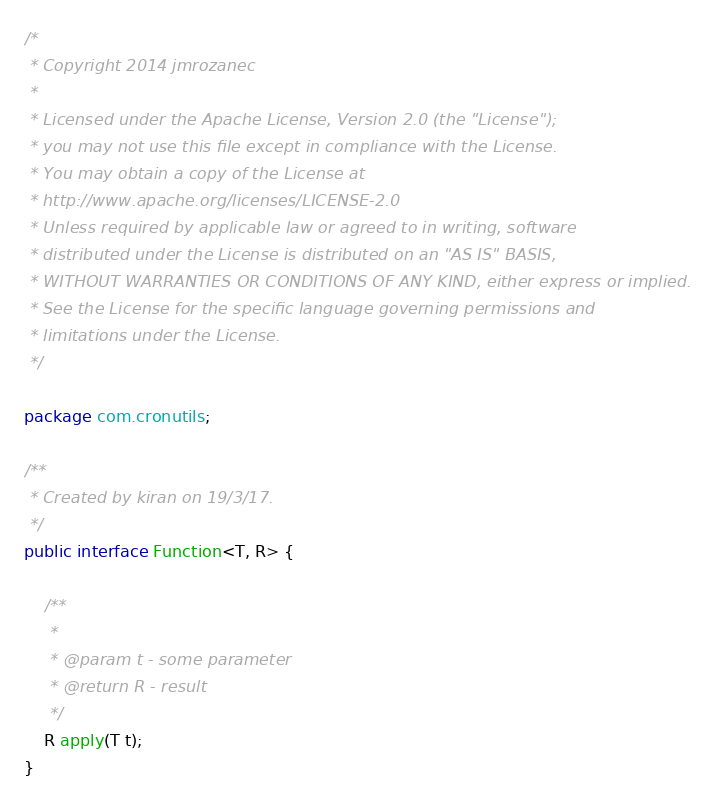<code> <loc_0><loc_0><loc_500><loc_500><_Java_>/*
 * Copyright 2014 jmrozanec
 *
 * Licensed under the Apache License, Version 2.0 (the "License");
 * you may not use this file except in compliance with the License.
 * You may obtain a copy of the License at
 * http://www.apache.org/licenses/LICENSE-2.0
 * Unless required by applicable law or agreed to in writing, software
 * distributed under the License is distributed on an "AS IS" BASIS,
 * WITHOUT WARRANTIES OR CONDITIONS OF ANY KIND, either express or implied.
 * See the License for the specific language governing permissions and
 * limitations under the License.
 */

package com.cronutils;

/**
 * Created by kiran on 19/3/17.
 */
public interface Function<T, R> {

    /**
     *
     * @param t - some parameter
     * @return R - result
     */
    R apply(T t);
}
</code> 